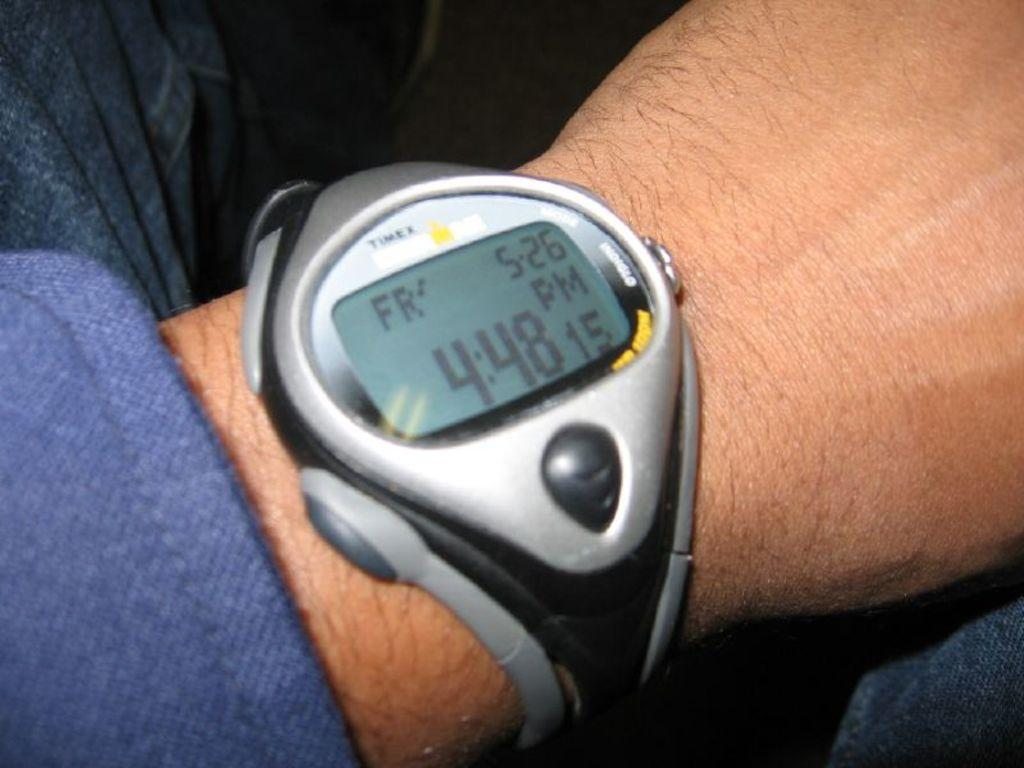<image>
Write a terse but informative summary of the picture. A digital watch says that the current time is 4:48 pm. 